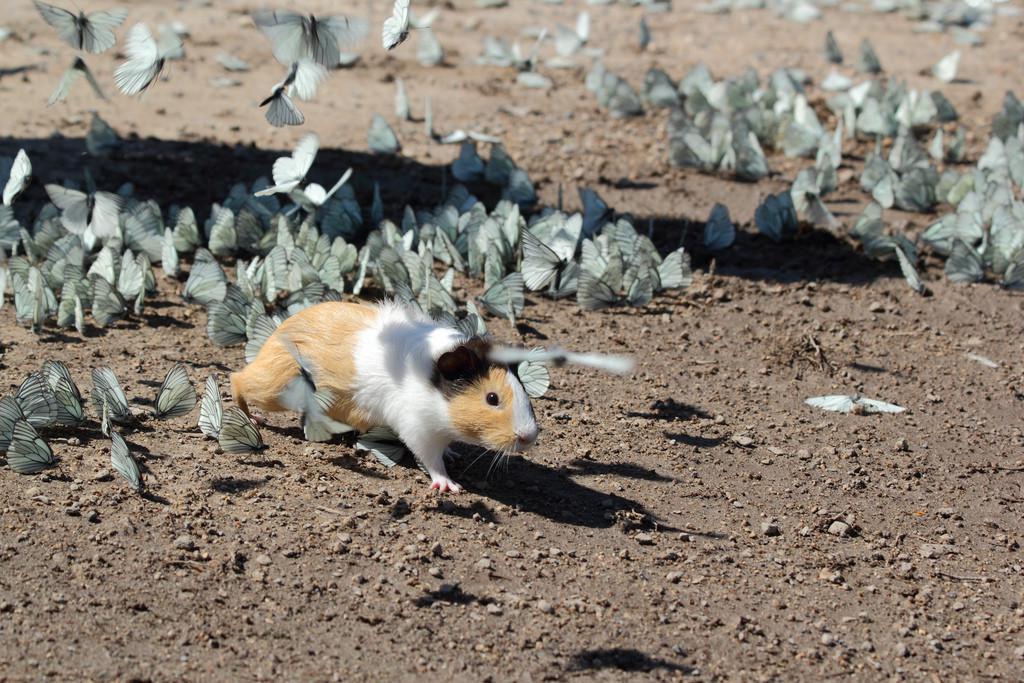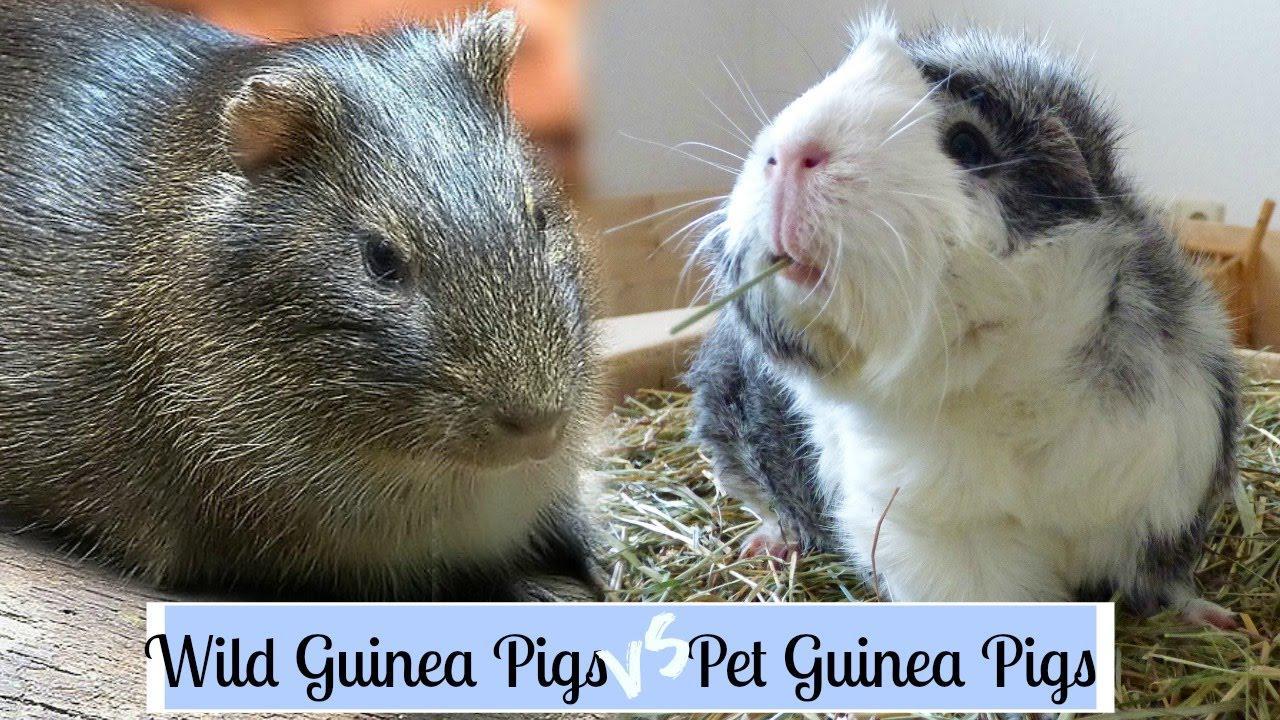The first image is the image on the left, the second image is the image on the right. Assess this claim about the two images: "There are two guinea pigs on the ground in the image on the right.". Correct or not? Answer yes or no. Yes. 